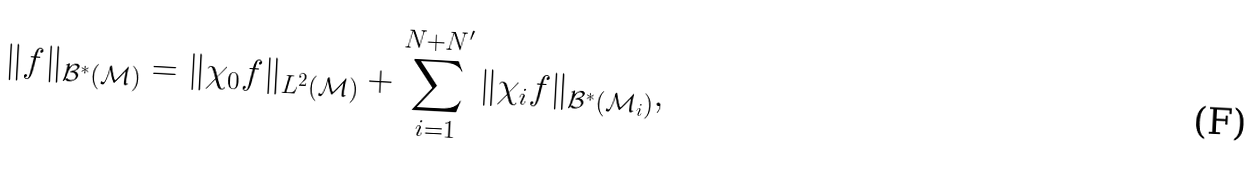<formula> <loc_0><loc_0><loc_500><loc_500>\| f \| _ { \mathcal { B } ^ { \ast } ( \mathcal { M } ) } = \| \chi _ { 0 } f \| _ { L ^ { 2 } ( \mathcal { M } ) } + \sum _ { i = 1 } ^ { N + N ^ { \prime } } \| \chi _ { i } f \| _ { \mathcal { B } ^ { \ast } ( \mathcal { M } _ { i } ) } ,</formula> 